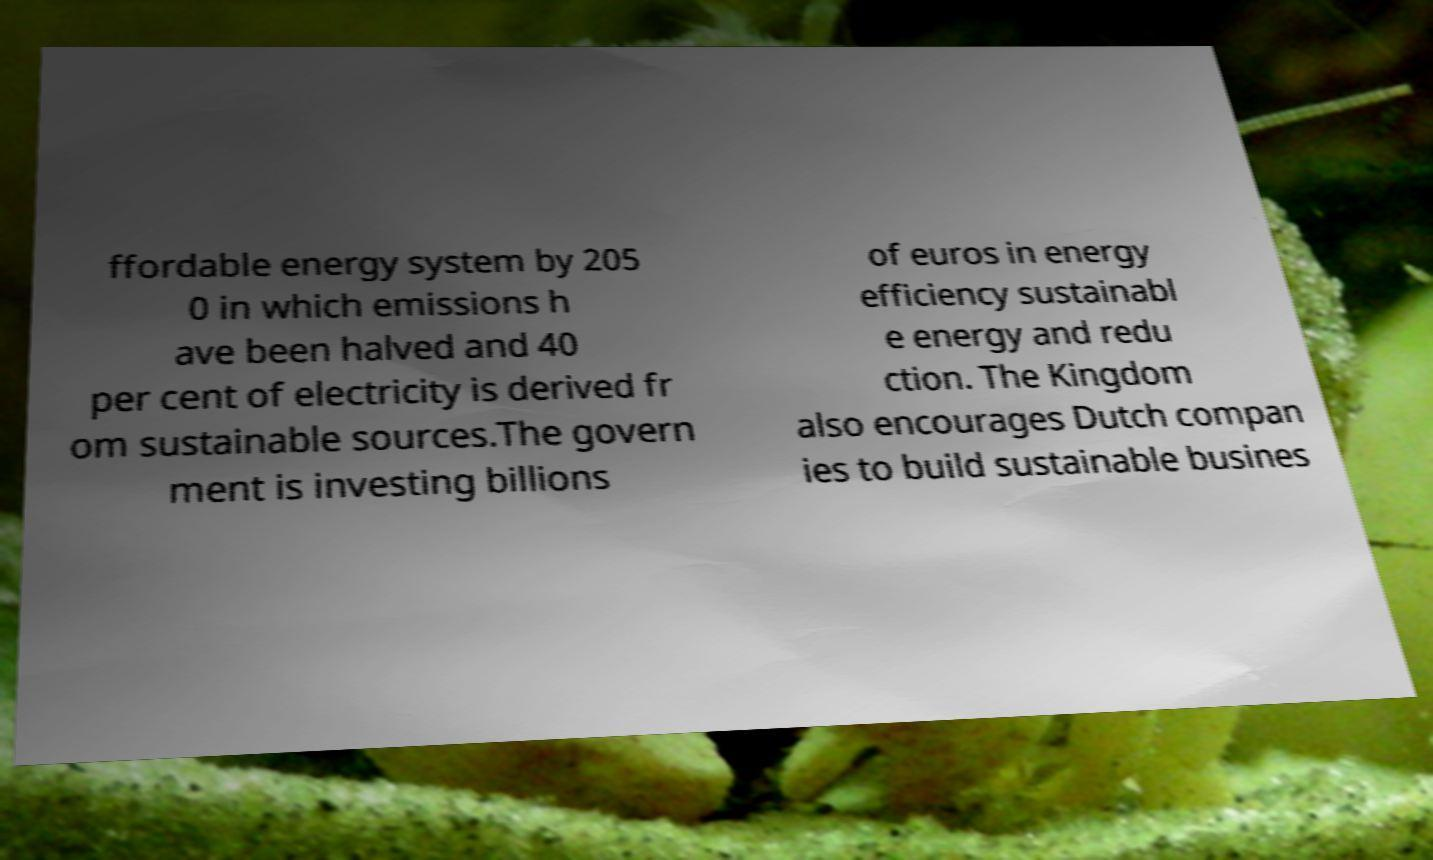Please identify and transcribe the text found in this image. ffordable energy system by 205 0 in which emissions h ave been halved and 40 per cent of electricity is derived fr om sustainable sources.The govern ment is investing billions of euros in energy efficiency sustainabl e energy and redu ction. The Kingdom also encourages Dutch compan ies to build sustainable busines 